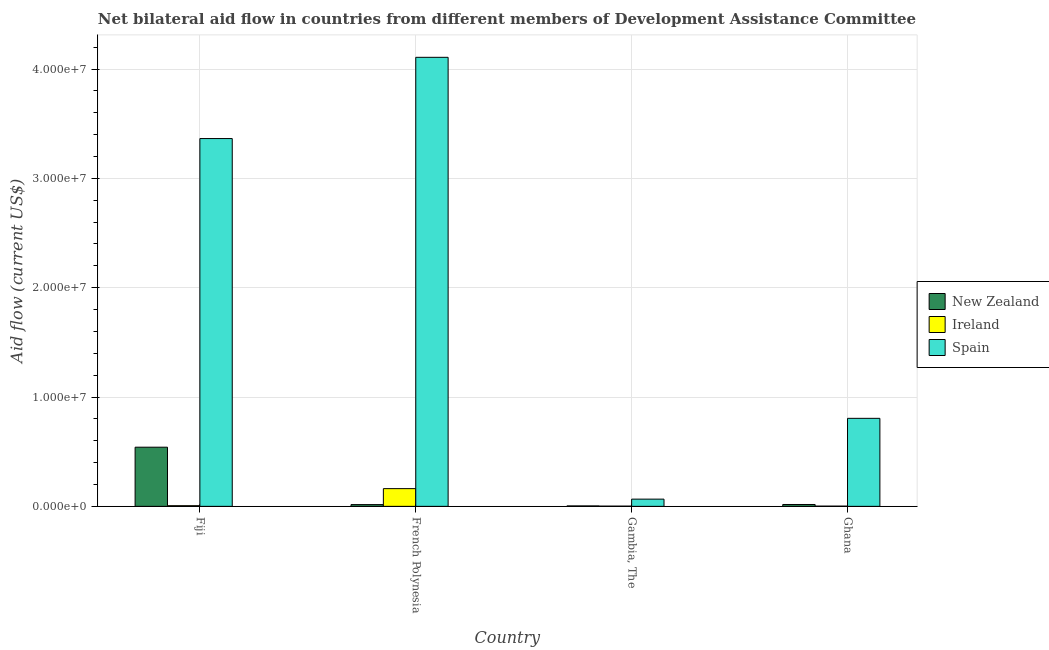How many different coloured bars are there?
Keep it short and to the point. 3. How many groups of bars are there?
Your response must be concise. 4. Are the number of bars per tick equal to the number of legend labels?
Give a very brief answer. Yes. How many bars are there on the 1st tick from the left?
Offer a very short reply. 3. How many bars are there on the 4th tick from the right?
Your answer should be very brief. 3. What is the label of the 3rd group of bars from the left?
Provide a short and direct response. Gambia, The. What is the amount of aid provided by ireland in French Polynesia?
Offer a very short reply. 1.62e+06. Across all countries, what is the maximum amount of aid provided by spain?
Offer a terse response. 4.11e+07. Across all countries, what is the minimum amount of aid provided by new zealand?
Offer a terse response. 4.00e+04. In which country was the amount of aid provided by new zealand maximum?
Make the answer very short. Fiji. In which country was the amount of aid provided by new zealand minimum?
Your answer should be compact. Gambia, The. What is the total amount of aid provided by ireland in the graph?
Ensure brevity in your answer.  1.72e+06. What is the difference between the amount of aid provided by ireland in Fiji and that in Gambia, The?
Your answer should be very brief. 4.00e+04. What is the difference between the amount of aid provided by ireland in Fiji and the amount of aid provided by new zealand in Gambia, The?
Give a very brief answer. 2.00e+04. What is the average amount of aid provided by spain per country?
Your answer should be compact. 2.09e+07. What is the difference between the amount of aid provided by ireland and amount of aid provided by new zealand in Fiji?
Ensure brevity in your answer.  -5.35e+06. What is the ratio of the amount of aid provided by ireland in Fiji to that in French Polynesia?
Provide a short and direct response. 0.04. What is the difference between the highest and the second highest amount of aid provided by spain?
Offer a very short reply. 7.43e+06. What is the difference between the highest and the lowest amount of aid provided by new zealand?
Your answer should be very brief. 5.37e+06. In how many countries, is the amount of aid provided by spain greater than the average amount of aid provided by spain taken over all countries?
Provide a short and direct response. 2. Is the sum of the amount of aid provided by ireland in Fiji and French Polynesia greater than the maximum amount of aid provided by new zealand across all countries?
Your answer should be compact. No. What does the 3rd bar from the left in Gambia, The represents?
Give a very brief answer. Spain. What does the 2nd bar from the right in Ghana represents?
Your response must be concise. Ireland. How many bars are there?
Ensure brevity in your answer.  12. Are all the bars in the graph horizontal?
Keep it short and to the point. No. How many countries are there in the graph?
Offer a very short reply. 4. Does the graph contain grids?
Offer a very short reply. Yes. How many legend labels are there?
Give a very brief answer. 3. What is the title of the graph?
Your response must be concise. Net bilateral aid flow in countries from different members of Development Assistance Committee. What is the label or title of the Y-axis?
Make the answer very short. Aid flow (current US$). What is the Aid flow (current US$) of New Zealand in Fiji?
Offer a terse response. 5.41e+06. What is the Aid flow (current US$) in Ireland in Fiji?
Provide a succinct answer. 6.00e+04. What is the Aid flow (current US$) of Spain in Fiji?
Offer a very short reply. 3.36e+07. What is the Aid flow (current US$) of Ireland in French Polynesia?
Provide a succinct answer. 1.62e+06. What is the Aid flow (current US$) of Spain in French Polynesia?
Provide a short and direct response. 4.11e+07. What is the Aid flow (current US$) in New Zealand in Gambia, The?
Make the answer very short. 4.00e+04. What is the Aid flow (current US$) in Spain in Ghana?
Provide a succinct answer. 8.05e+06. Across all countries, what is the maximum Aid flow (current US$) in New Zealand?
Your response must be concise. 5.41e+06. Across all countries, what is the maximum Aid flow (current US$) in Ireland?
Give a very brief answer. 1.62e+06. Across all countries, what is the maximum Aid flow (current US$) of Spain?
Your answer should be compact. 4.11e+07. What is the total Aid flow (current US$) of New Zealand in the graph?
Ensure brevity in your answer.  5.78e+06. What is the total Aid flow (current US$) of Ireland in the graph?
Keep it short and to the point. 1.72e+06. What is the total Aid flow (current US$) of Spain in the graph?
Make the answer very short. 8.34e+07. What is the difference between the Aid flow (current US$) in New Zealand in Fiji and that in French Polynesia?
Your answer should be very brief. 5.25e+06. What is the difference between the Aid flow (current US$) of Ireland in Fiji and that in French Polynesia?
Keep it short and to the point. -1.56e+06. What is the difference between the Aid flow (current US$) in Spain in Fiji and that in French Polynesia?
Your response must be concise. -7.43e+06. What is the difference between the Aid flow (current US$) of New Zealand in Fiji and that in Gambia, The?
Offer a very short reply. 5.37e+06. What is the difference between the Aid flow (current US$) of Spain in Fiji and that in Gambia, The?
Your answer should be very brief. 3.30e+07. What is the difference between the Aid flow (current US$) in New Zealand in Fiji and that in Ghana?
Offer a very short reply. 5.24e+06. What is the difference between the Aid flow (current US$) of Ireland in Fiji and that in Ghana?
Your response must be concise. 4.00e+04. What is the difference between the Aid flow (current US$) in Spain in Fiji and that in Ghana?
Your answer should be compact. 2.56e+07. What is the difference between the Aid flow (current US$) in New Zealand in French Polynesia and that in Gambia, The?
Make the answer very short. 1.20e+05. What is the difference between the Aid flow (current US$) in Ireland in French Polynesia and that in Gambia, The?
Your answer should be very brief. 1.60e+06. What is the difference between the Aid flow (current US$) of Spain in French Polynesia and that in Gambia, The?
Your answer should be compact. 4.04e+07. What is the difference between the Aid flow (current US$) in Ireland in French Polynesia and that in Ghana?
Give a very brief answer. 1.60e+06. What is the difference between the Aid flow (current US$) in Spain in French Polynesia and that in Ghana?
Your response must be concise. 3.30e+07. What is the difference between the Aid flow (current US$) in New Zealand in Gambia, The and that in Ghana?
Offer a terse response. -1.30e+05. What is the difference between the Aid flow (current US$) in Spain in Gambia, The and that in Ghana?
Provide a short and direct response. -7.39e+06. What is the difference between the Aid flow (current US$) of New Zealand in Fiji and the Aid flow (current US$) of Ireland in French Polynesia?
Give a very brief answer. 3.79e+06. What is the difference between the Aid flow (current US$) of New Zealand in Fiji and the Aid flow (current US$) of Spain in French Polynesia?
Make the answer very short. -3.57e+07. What is the difference between the Aid flow (current US$) of Ireland in Fiji and the Aid flow (current US$) of Spain in French Polynesia?
Offer a very short reply. -4.10e+07. What is the difference between the Aid flow (current US$) in New Zealand in Fiji and the Aid flow (current US$) in Ireland in Gambia, The?
Provide a short and direct response. 5.39e+06. What is the difference between the Aid flow (current US$) in New Zealand in Fiji and the Aid flow (current US$) in Spain in Gambia, The?
Your response must be concise. 4.75e+06. What is the difference between the Aid flow (current US$) of Ireland in Fiji and the Aid flow (current US$) of Spain in Gambia, The?
Provide a succinct answer. -6.00e+05. What is the difference between the Aid flow (current US$) in New Zealand in Fiji and the Aid flow (current US$) in Ireland in Ghana?
Your answer should be compact. 5.39e+06. What is the difference between the Aid flow (current US$) in New Zealand in Fiji and the Aid flow (current US$) in Spain in Ghana?
Offer a terse response. -2.64e+06. What is the difference between the Aid flow (current US$) of Ireland in Fiji and the Aid flow (current US$) of Spain in Ghana?
Your answer should be very brief. -7.99e+06. What is the difference between the Aid flow (current US$) of New Zealand in French Polynesia and the Aid flow (current US$) of Spain in Gambia, The?
Provide a short and direct response. -5.00e+05. What is the difference between the Aid flow (current US$) in Ireland in French Polynesia and the Aid flow (current US$) in Spain in Gambia, The?
Offer a very short reply. 9.60e+05. What is the difference between the Aid flow (current US$) in New Zealand in French Polynesia and the Aid flow (current US$) in Ireland in Ghana?
Your answer should be very brief. 1.40e+05. What is the difference between the Aid flow (current US$) of New Zealand in French Polynesia and the Aid flow (current US$) of Spain in Ghana?
Give a very brief answer. -7.89e+06. What is the difference between the Aid flow (current US$) in Ireland in French Polynesia and the Aid flow (current US$) in Spain in Ghana?
Offer a terse response. -6.43e+06. What is the difference between the Aid flow (current US$) of New Zealand in Gambia, The and the Aid flow (current US$) of Ireland in Ghana?
Make the answer very short. 2.00e+04. What is the difference between the Aid flow (current US$) in New Zealand in Gambia, The and the Aid flow (current US$) in Spain in Ghana?
Your response must be concise. -8.01e+06. What is the difference between the Aid flow (current US$) in Ireland in Gambia, The and the Aid flow (current US$) in Spain in Ghana?
Provide a succinct answer. -8.03e+06. What is the average Aid flow (current US$) of New Zealand per country?
Your answer should be compact. 1.44e+06. What is the average Aid flow (current US$) in Ireland per country?
Offer a terse response. 4.30e+05. What is the average Aid flow (current US$) in Spain per country?
Your answer should be very brief. 2.09e+07. What is the difference between the Aid flow (current US$) of New Zealand and Aid flow (current US$) of Ireland in Fiji?
Your answer should be compact. 5.35e+06. What is the difference between the Aid flow (current US$) of New Zealand and Aid flow (current US$) of Spain in Fiji?
Provide a succinct answer. -2.82e+07. What is the difference between the Aid flow (current US$) of Ireland and Aid flow (current US$) of Spain in Fiji?
Your response must be concise. -3.36e+07. What is the difference between the Aid flow (current US$) of New Zealand and Aid flow (current US$) of Ireland in French Polynesia?
Give a very brief answer. -1.46e+06. What is the difference between the Aid flow (current US$) in New Zealand and Aid flow (current US$) in Spain in French Polynesia?
Provide a short and direct response. -4.09e+07. What is the difference between the Aid flow (current US$) in Ireland and Aid flow (current US$) in Spain in French Polynesia?
Offer a very short reply. -3.94e+07. What is the difference between the Aid flow (current US$) of New Zealand and Aid flow (current US$) of Spain in Gambia, The?
Your answer should be very brief. -6.20e+05. What is the difference between the Aid flow (current US$) of Ireland and Aid flow (current US$) of Spain in Gambia, The?
Offer a terse response. -6.40e+05. What is the difference between the Aid flow (current US$) of New Zealand and Aid flow (current US$) of Ireland in Ghana?
Ensure brevity in your answer.  1.50e+05. What is the difference between the Aid flow (current US$) in New Zealand and Aid flow (current US$) in Spain in Ghana?
Provide a short and direct response. -7.88e+06. What is the difference between the Aid flow (current US$) of Ireland and Aid flow (current US$) of Spain in Ghana?
Offer a very short reply. -8.03e+06. What is the ratio of the Aid flow (current US$) in New Zealand in Fiji to that in French Polynesia?
Provide a short and direct response. 33.81. What is the ratio of the Aid flow (current US$) in Ireland in Fiji to that in French Polynesia?
Keep it short and to the point. 0.04. What is the ratio of the Aid flow (current US$) of Spain in Fiji to that in French Polynesia?
Ensure brevity in your answer.  0.82. What is the ratio of the Aid flow (current US$) of New Zealand in Fiji to that in Gambia, The?
Keep it short and to the point. 135.25. What is the ratio of the Aid flow (current US$) in Ireland in Fiji to that in Gambia, The?
Your answer should be compact. 3. What is the ratio of the Aid flow (current US$) of Spain in Fiji to that in Gambia, The?
Offer a very short reply. 50.97. What is the ratio of the Aid flow (current US$) of New Zealand in Fiji to that in Ghana?
Your response must be concise. 31.82. What is the ratio of the Aid flow (current US$) of Ireland in Fiji to that in Ghana?
Offer a terse response. 3. What is the ratio of the Aid flow (current US$) in Spain in Fiji to that in Ghana?
Provide a short and direct response. 4.18. What is the ratio of the Aid flow (current US$) of New Zealand in French Polynesia to that in Gambia, The?
Ensure brevity in your answer.  4. What is the ratio of the Aid flow (current US$) in Spain in French Polynesia to that in Gambia, The?
Offer a very short reply. 62.23. What is the ratio of the Aid flow (current US$) in New Zealand in French Polynesia to that in Ghana?
Your answer should be compact. 0.94. What is the ratio of the Aid flow (current US$) of Spain in French Polynesia to that in Ghana?
Give a very brief answer. 5.1. What is the ratio of the Aid flow (current US$) in New Zealand in Gambia, The to that in Ghana?
Your response must be concise. 0.24. What is the ratio of the Aid flow (current US$) of Spain in Gambia, The to that in Ghana?
Your response must be concise. 0.08. What is the difference between the highest and the second highest Aid flow (current US$) of New Zealand?
Offer a very short reply. 5.24e+06. What is the difference between the highest and the second highest Aid flow (current US$) in Ireland?
Provide a succinct answer. 1.56e+06. What is the difference between the highest and the second highest Aid flow (current US$) in Spain?
Provide a short and direct response. 7.43e+06. What is the difference between the highest and the lowest Aid flow (current US$) of New Zealand?
Give a very brief answer. 5.37e+06. What is the difference between the highest and the lowest Aid flow (current US$) of Ireland?
Offer a very short reply. 1.60e+06. What is the difference between the highest and the lowest Aid flow (current US$) of Spain?
Provide a short and direct response. 4.04e+07. 